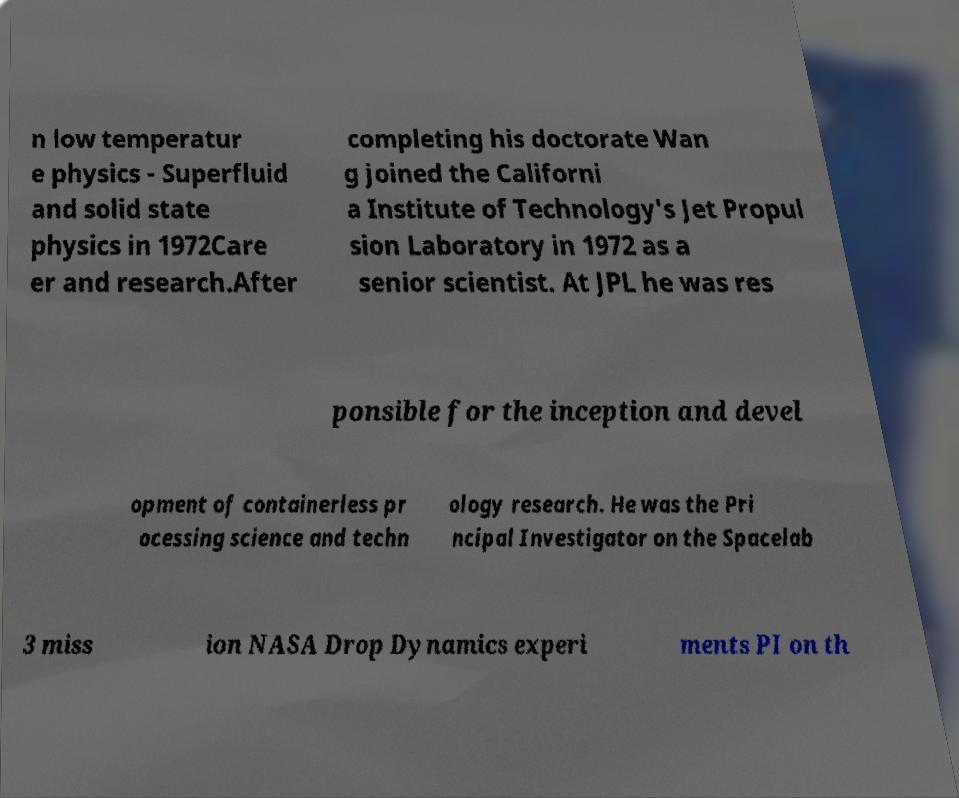There's text embedded in this image that I need extracted. Can you transcribe it verbatim? n low temperatur e physics - Superfluid and solid state physics in 1972Care er and research.After completing his doctorate Wan g joined the Californi a Institute of Technology's Jet Propul sion Laboratory in 1972 as a senior scientist. At JPL he was res ponsible for the inception and devel opment of containerless pr ocessing science and techn ology research. He was the Pri ncipal Investigator on the Spacelab 3 miss ion NASA Drop Dynamics experi ments PI on th 